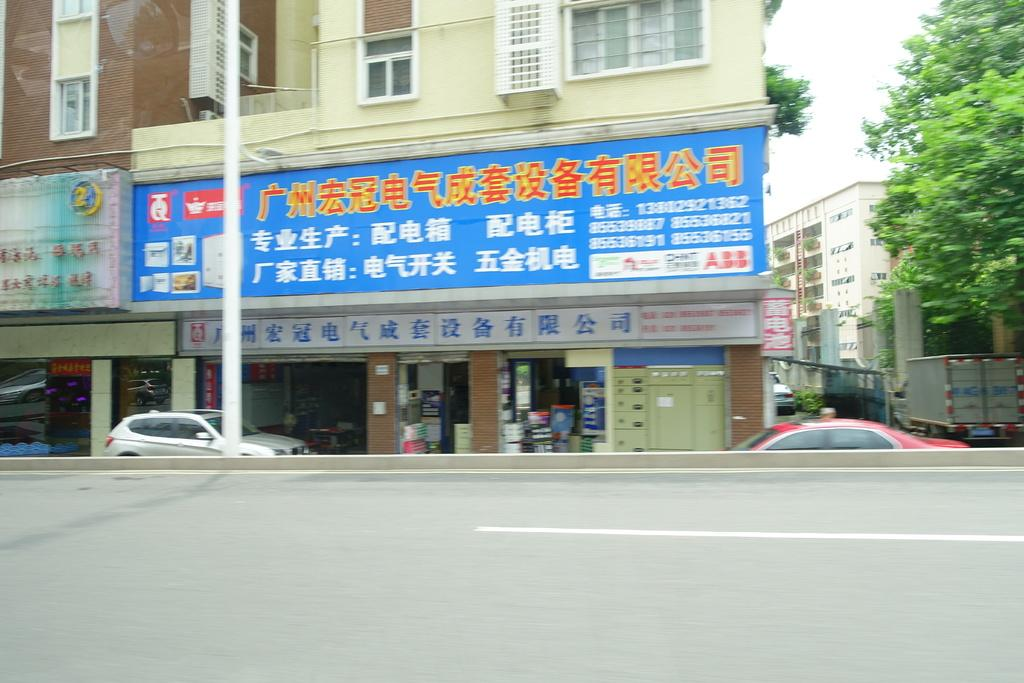What type of structures can be seen in the image? There are buildings in the image. What other natural elements are present in the image? There are trees in the image. Are there any man-made objects visible besides buildings? Yes, there are vehicles in the image. What is the purpose of the pole in the image? The pole's purpose is not specified, but it could be for signage or lighting. What type of surface can be seen in the image? There is a road in the image. What is visible in the background of the image? The sky is visible in the image. How many fingers can be seen attempting to climb the tree in the image? There are no fingers or attempts to climb a tree visible in the image. What type of tub is present in the image? There is no tub present in the image. 